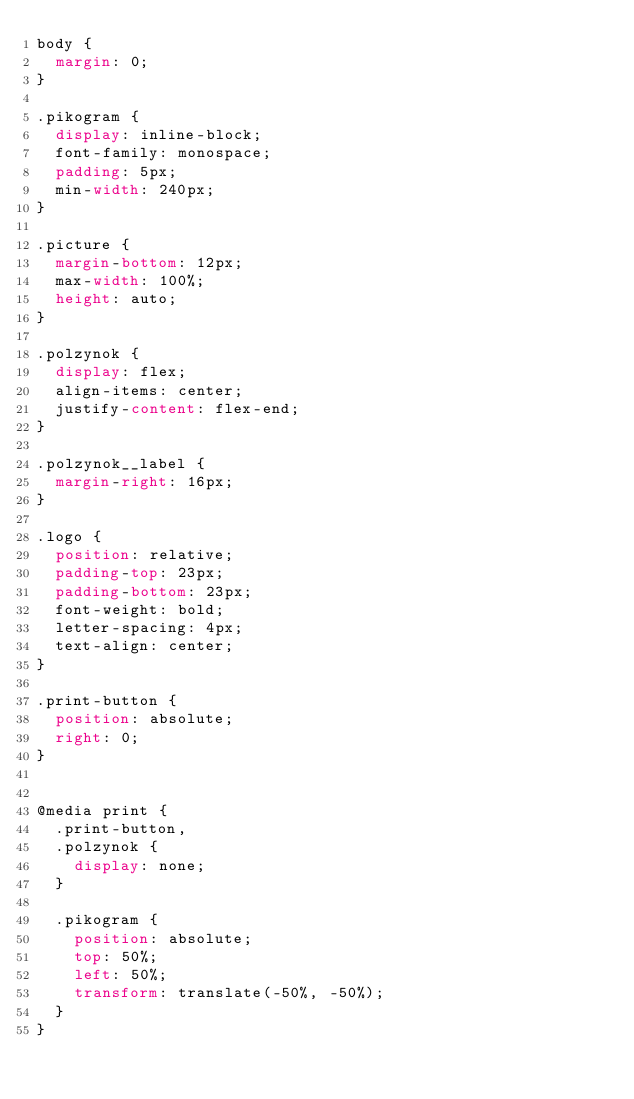Convert code to text. <code><loc_0><loc_0><loc_500><loc_500><_CSS_>body {
  margin: 0;
}

.pikogram {
  display: inline-block;
  font-family: monospace;
  padding: 5px;
  min-width: 240px;
}

.picture {
  margin-bottom: 12px;
  max-width: 100%;
  height: auto;
}

.polzynok {
  display: flex;
  align-items: center;
  justify-content: flex-end;
}

.polzynok__label {
  margin-right: 16px;
}

.logo {
  position: relative;
  padding-top: 23px;
  padding-bottom: 23px;
  font-weight: bold;
  letter-spacing: 4px;
  text-align: center;
}

.print-button {
  position: absolute;
  right: 0;
}


@media print {
  .print-button,
  .polzynok {
    display: none;
  }

  .pikogram {
    position: absolute;
    top: 50%;
    left: 50%;
    transform: translate(-50%, -50%);
  }
}
</code> 